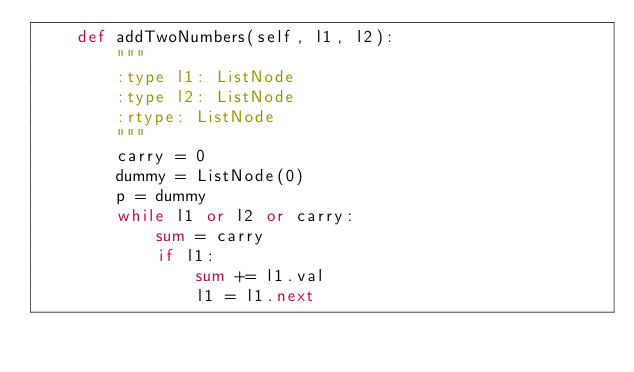<code> <loc_0><loc_0><loc_500><loc_500><_Python_>    def addTwoNumbers(self, l1, l2):
        """
        :type l1: ListNode
        :type l2: ListNode
        :rtype: ListNode
        """
        carry = 0
        dummy = ListNode(0)
        p = dummy
        while l1 or l2 or carry:
            sum = carry
            if l1:
                sum += l1.val
                l1 = l1.next</code> 